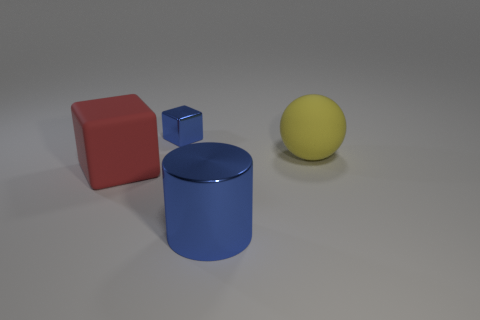Do the matte thing that is left of the cylinder and the thing behind the big yellow object have the same size?
Ensure brevity in your answer.  No. Are there any large spheres made of the same material as the red cube?
Keep it short and to the point. Yes. What number of things are either large things left of the small object or blue cylinders?
Offer a terse response. 2. Is the block that is behind the large matte sphere made of the same material as the blue cylinder?
Provide a succinct answer. Yes. Is the tiny metal object the same shape as the yellow rubber thing?
Your response must be concise. No. There is a block that is behind the yellow rubber object; how many yellow balls are to the right of it?
Your answer should be compact. 1. There is a large thing that is the same shape as the tiny blue shiny object; what is its material?
Your response must be concise. Rubber. Is the color of the object that is behind the yellow matte object the same as the big cylinder?
Offer a terse response. Yes. Is the material of the cylinder the same as the thing that is behind the yellow rubber sphere?
Make the answer very short. Yes. What shape is the blue metallic thing that is in front of the big red rubber object?
Give a very brief answer. Cylinder. 